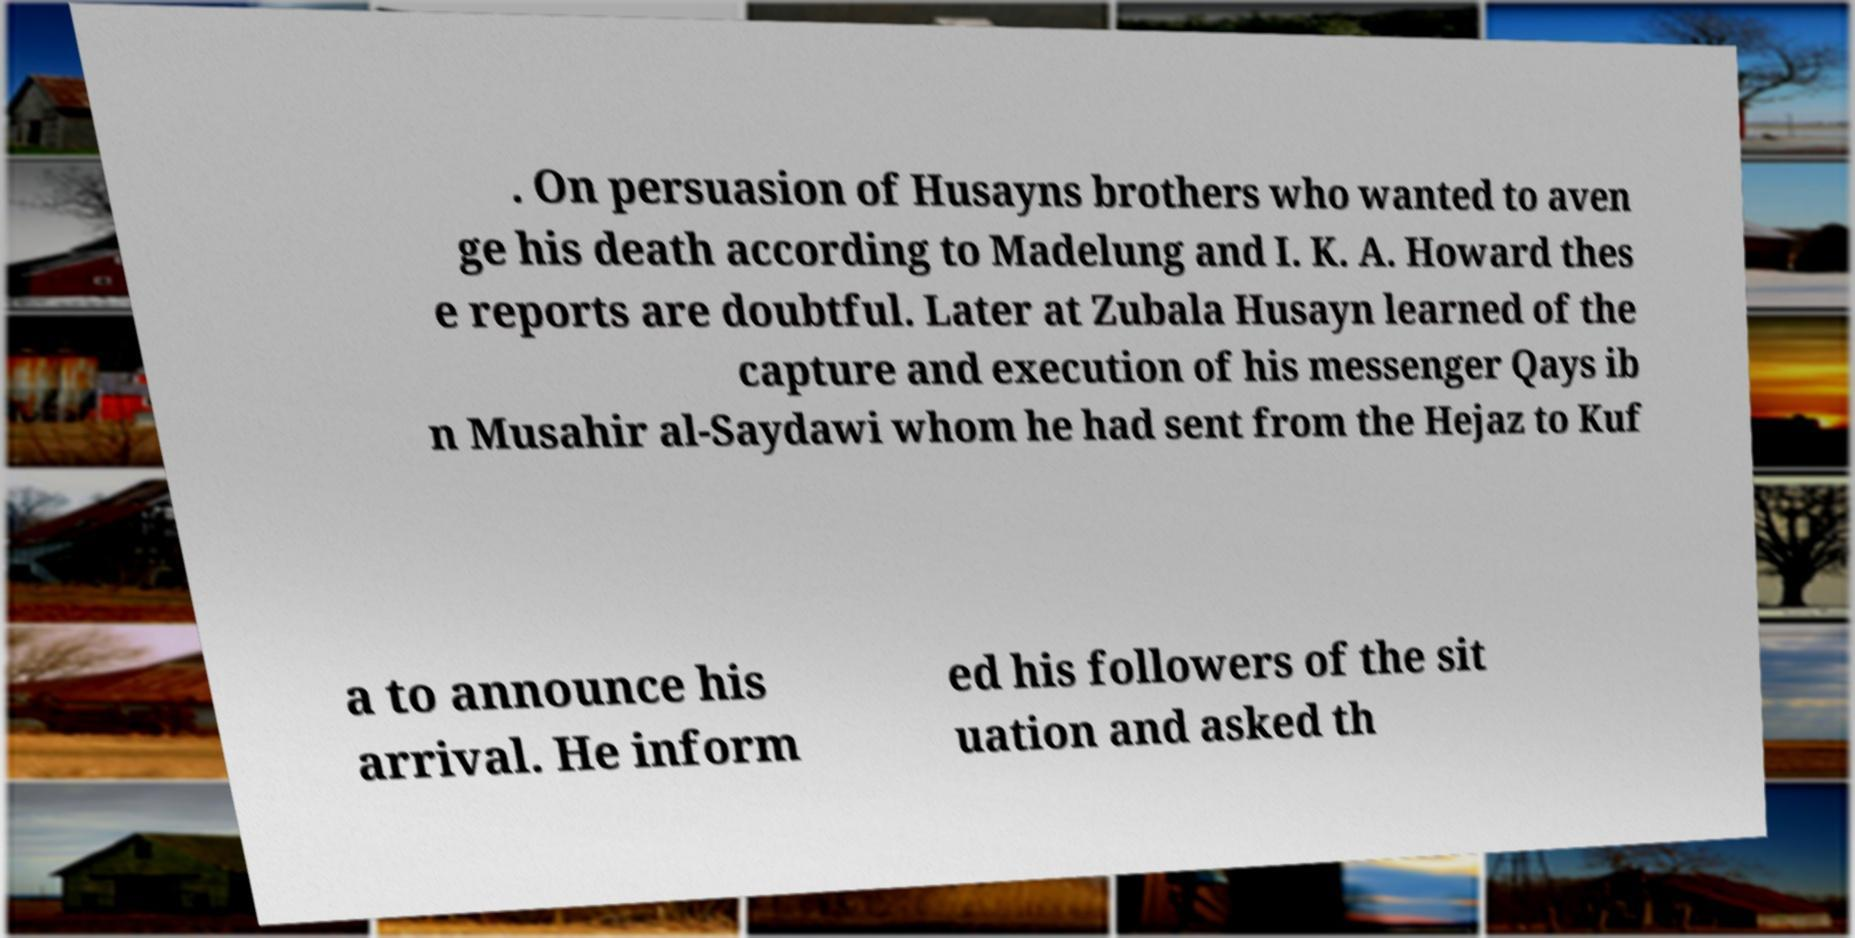Please identify and transcribe the text found in this image. . On persuasion of Husayns brothers who wanted to aven ge his death according to Madelung and I. K. A. Howard thes e reports are doubtful. Later at Zubala Husayn learned of the capture and execution of his messenger Qays ib n Musahir al-Saydawi whom he had sent from the Hejaz to Kuf a to announce his arrival. He inform ed his followers of the sit uation and asked th 